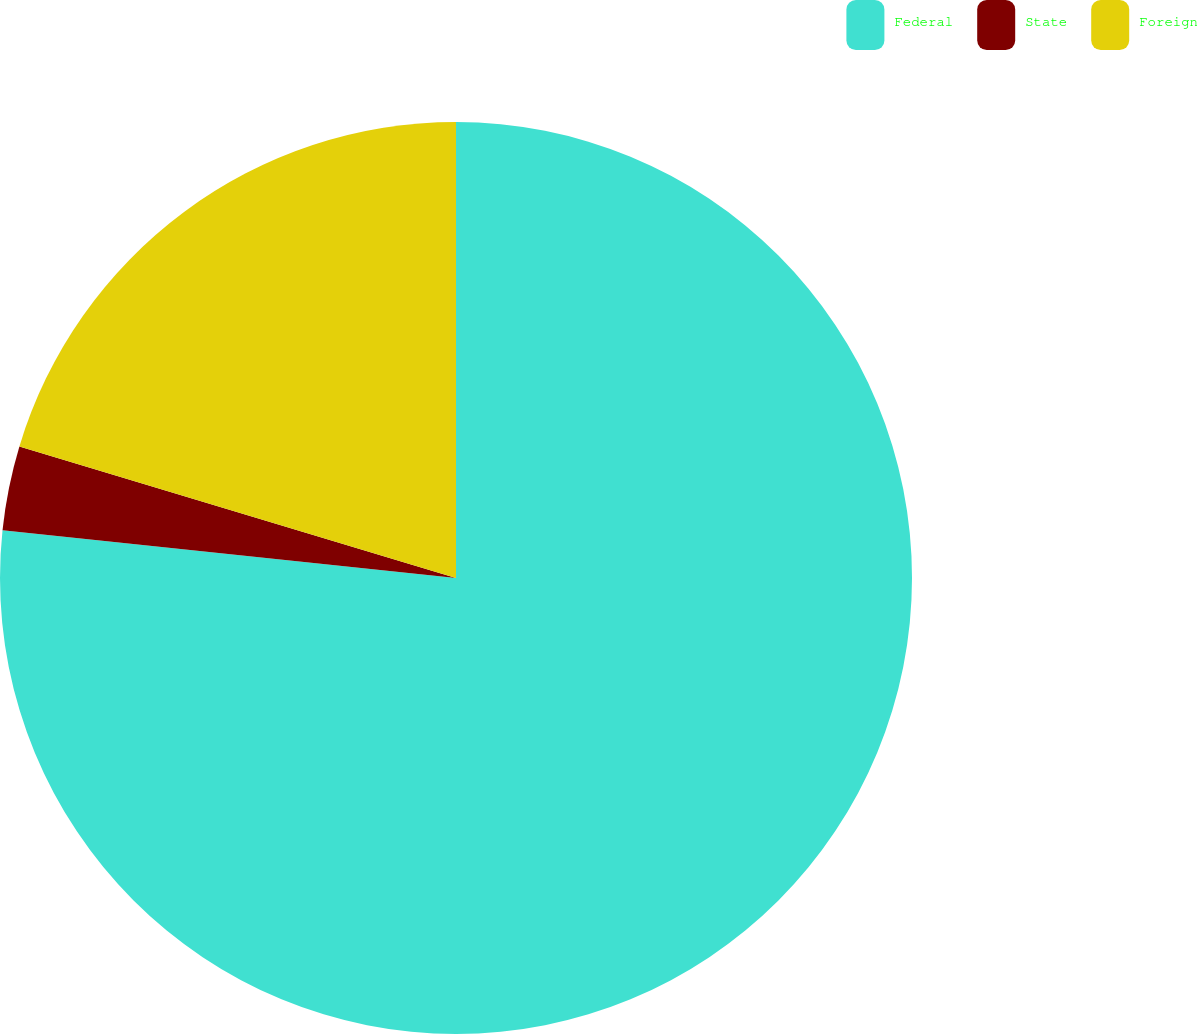Convert chart. <chart><loc_0><loc_0><loc_500><loc_500><pie_chart><fcel>Federal<fcel>State<fcel>Foreign<nl><fcel>76.67%<fcel>2.99%<fcel>20.34%<nl></chart> 